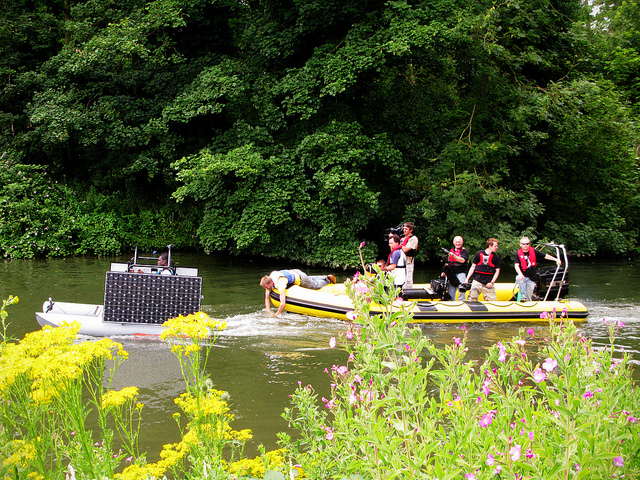How many boats are there? There are two boats in the image. One appears to be a standard raft with several people on it, possibly engaged in a leisure activity, and the other might be carrying audio equipment, possibly for an event or announcement. 